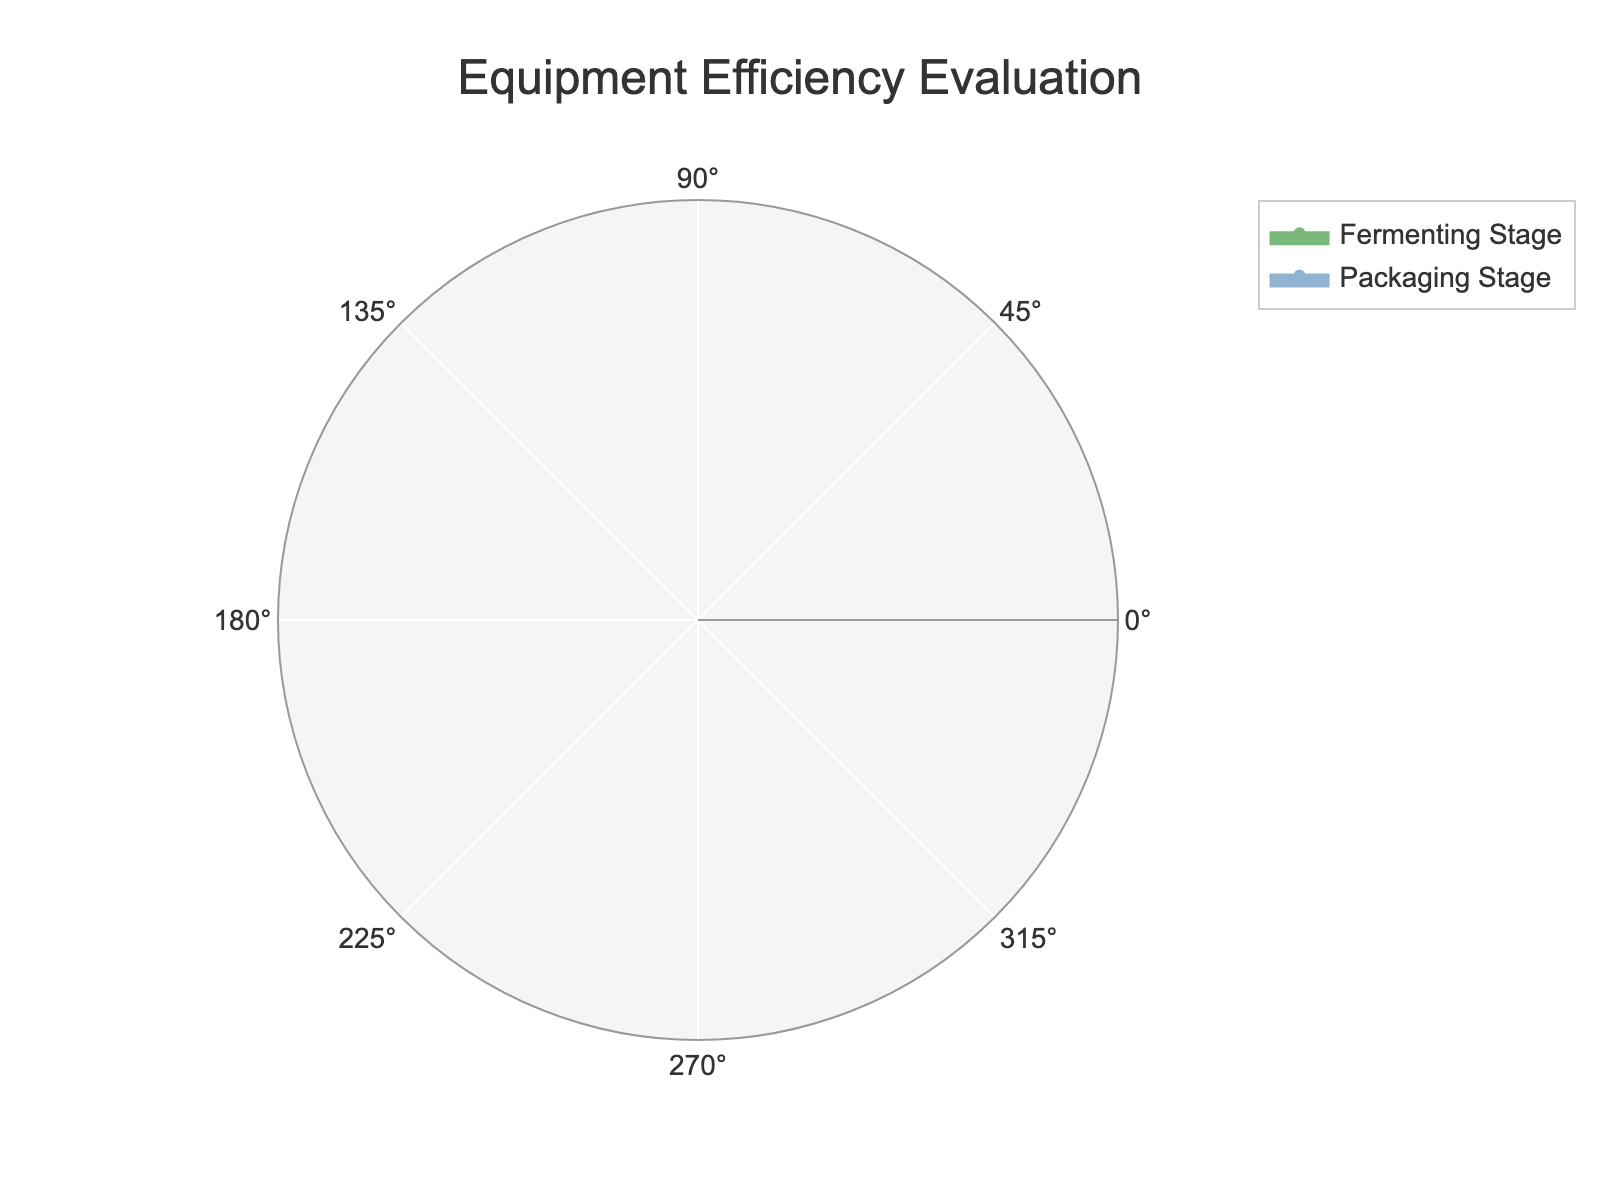What's the title of the chart? The title of the chart is located at the top center. The title text reads "Equipment Efficiency Evaluation".
Answer: Equipment Efficiency Evaluation How many categories are evaluated under the Brewing Stage? In the Brewing Stage, there are three categories: Mashing, Boiling, and Cooling. This is visible by observing the labels within the corresponding section of the radar chart.
Answer: Three Which stage has the highest efficiency in bottling? Each stage is evaluated by its specific processes. The packaging stage includes bottling, where the efficiency is 90%. This can be identified from the labeled data points on the radar chart.
Answer: Packaging Stage What is the average efficiency of the Fermenting Stage? The Fermenting Stage has three categories: Primary Fermentation (85%), Secondary Fermentation (88%), and Conditioning (80%). The average is calculated as (85 + 88 + 80) / 3 = 84.33%.
Answer: 84.33% In which category of the Brewing Stage is the efficiency lowest? Looking at the specific categories under the Brewing Stage, the efficiencies are Mashing (78%), Boiling (82%), and Cooling (76%). Cooling has the lowest efficiency at 76%.
Answer: Cooling How does the highest efficiency in the Fermenting Stage compare to the highest efficiency in the Packaging Stage? The highest efficiency in the Fermenting Stage is Secondary Fermentation at 88%. The highest efficiency in the Packaging Stage is Bottling at 90%. Bottling is higher by 2 percentage points.
Answer: Bottling is 2% higher Which stage shows the most consistent efficiency values? Consistency can be evaluated by the range (difference between highest and lowest efficiencies). The Brewing Stage ranges from 76% to 82% (6% range), Fermenting Stage from 80% to 88% (8% range), and Packaging Stage from 85% to 90% (5% range). The Packaging Stage has the smallest range and is the most consistent.
Answer: Packaging Stage What's the efficiency difference between Mashing and Kegging? From the Brewing and Packaging stages, the efficiencies are Mashing (78%) and Kegging (87%). The difference is 87% - 78% = 9%.
Answer: 9% Which category has higher efficiency: Primary Fermentation or Secondary Fermentation? Comparing the two categories in the Fermenting Stage: Primary Fermentation has 85% efficiency and Secondary Fermentation has 88% efficiency. Secondary Fermentation is higher.
Answer: Secondary Fermentation 